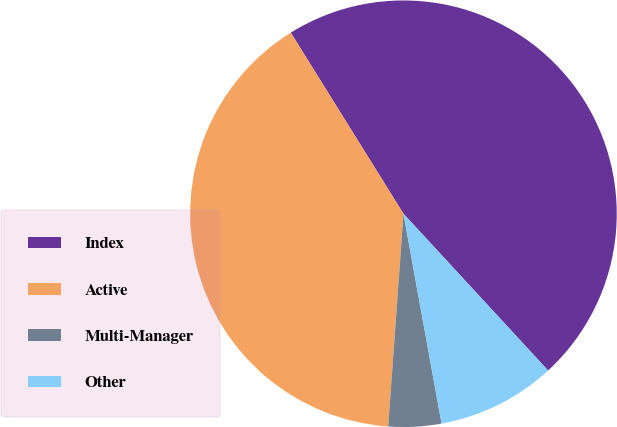<chart> <loc_0><loc_0><loc_500><loc_500><pie_chart><fcel>Index<fcel>Active<fcel>Multi-Manager<fcel>Other<nl><fcel>47.0%<fcel>40.0%<fcel>4.0%<fcel>9.0%<nl></chart> 